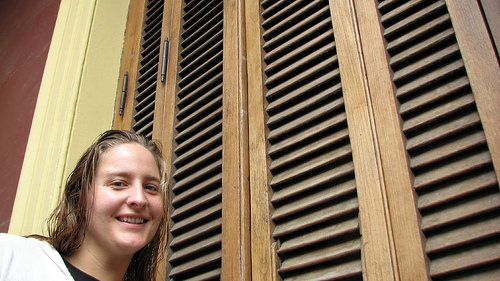<image>
Is the women behind the shutters? No. The women is not behind the shutters. From this viewpoint, the women appears to be positioned elsewhere in the scene. Where is the girl in relation to the shutters? Is it in the shutters? No. The girl is not contained within the shutters. These objects have a different spatial relationship. 